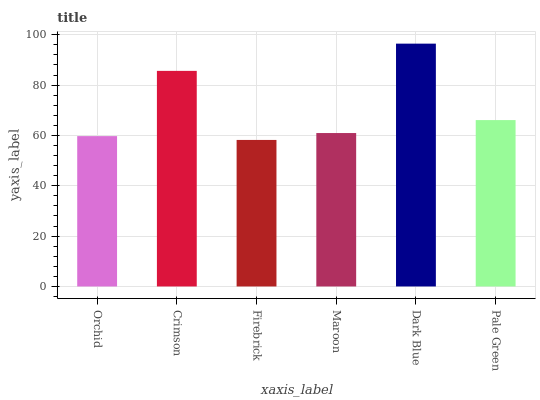Is Firebrick the minimum?
Answer yes or no. Yes. Is Dark Blue the maximum?
Answer yes or no. Yes. Is Crimson the minimum?
Answer yes or no. No. Is Crimson the maximum?
Answer yes or no. No. Is Crimson greater than Orchid?
Answer yes or no. Yes. Is Orchid less than Crimson?
Answer yes or no. Yes. Is Orchid greater than Crimson?
Answer yes or no. No. Is Crimson less than Orchid?
Answer yes or no. No. Is Pale Green the high median?
Answer yes or no. Yes. Is Maroon the low median?
Answer yes or no. Yes. Is Orchid the high median?
Answer yes or no. No. Is Firebrick the low median?
Answer yes or no. No. 